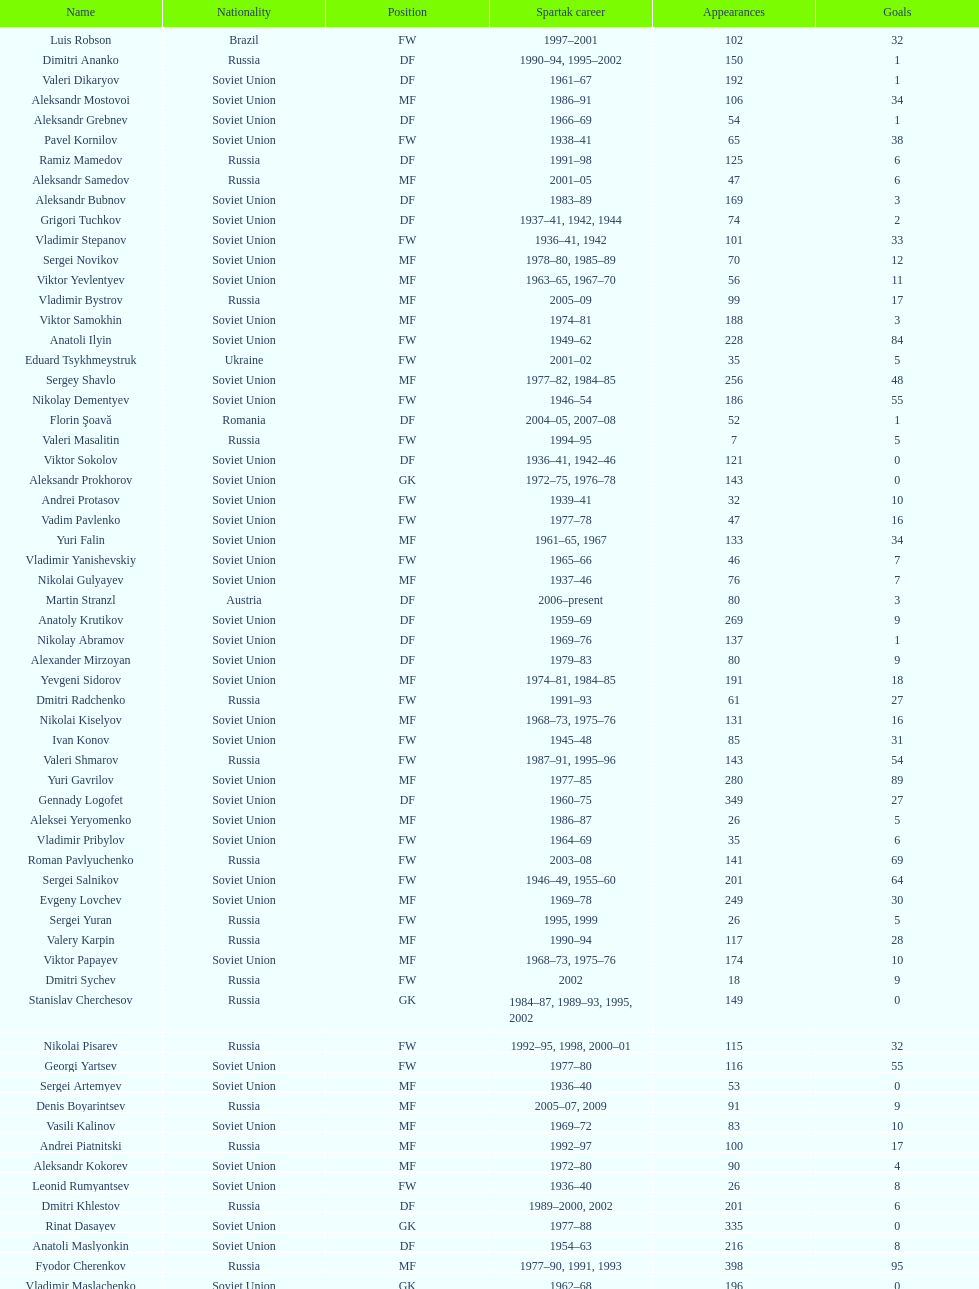Which player has the most appearances with the club? Fyodor Cherenkov. 